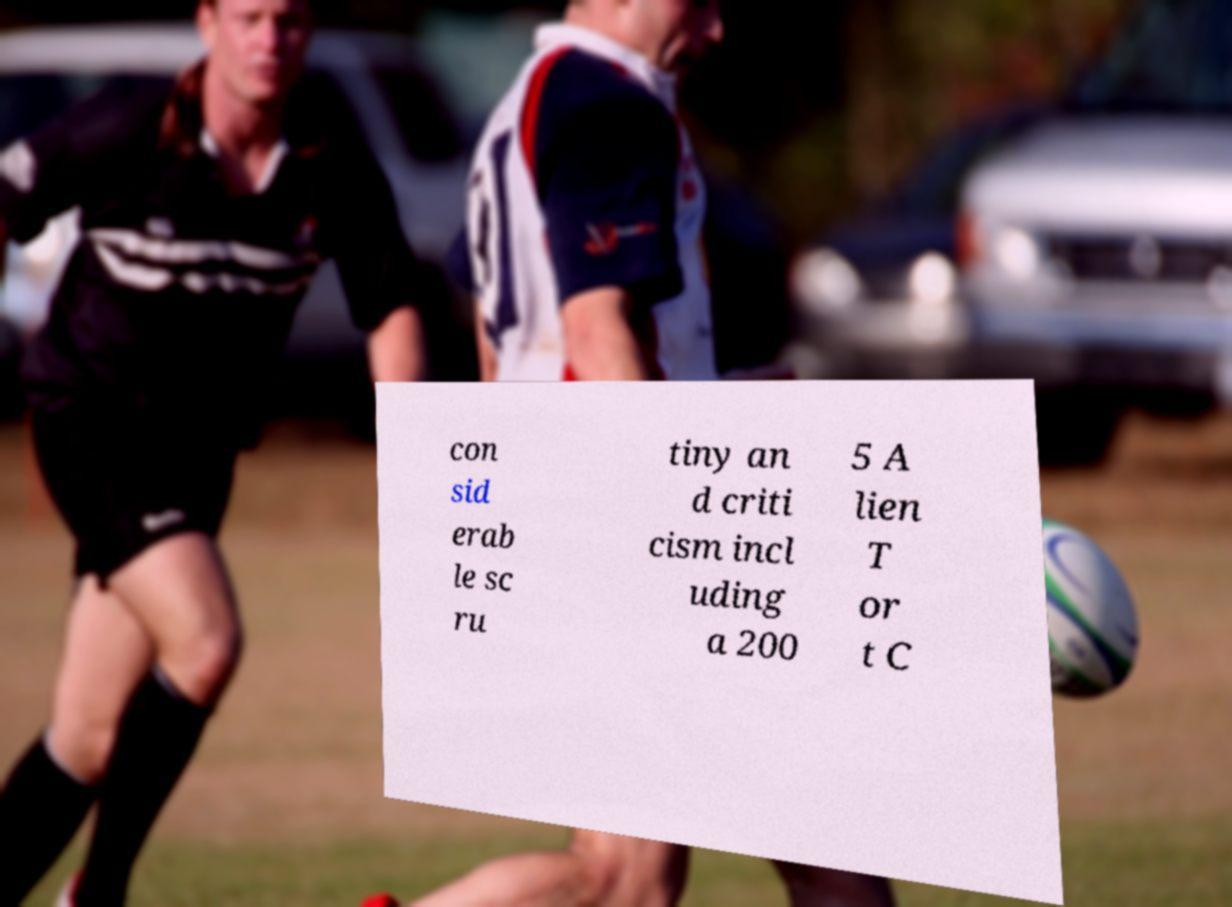Could you extract and type out the text from this image? con sid erab le sc ru tiny an d criti cism incl uding a 200 5 A lien T or t C 